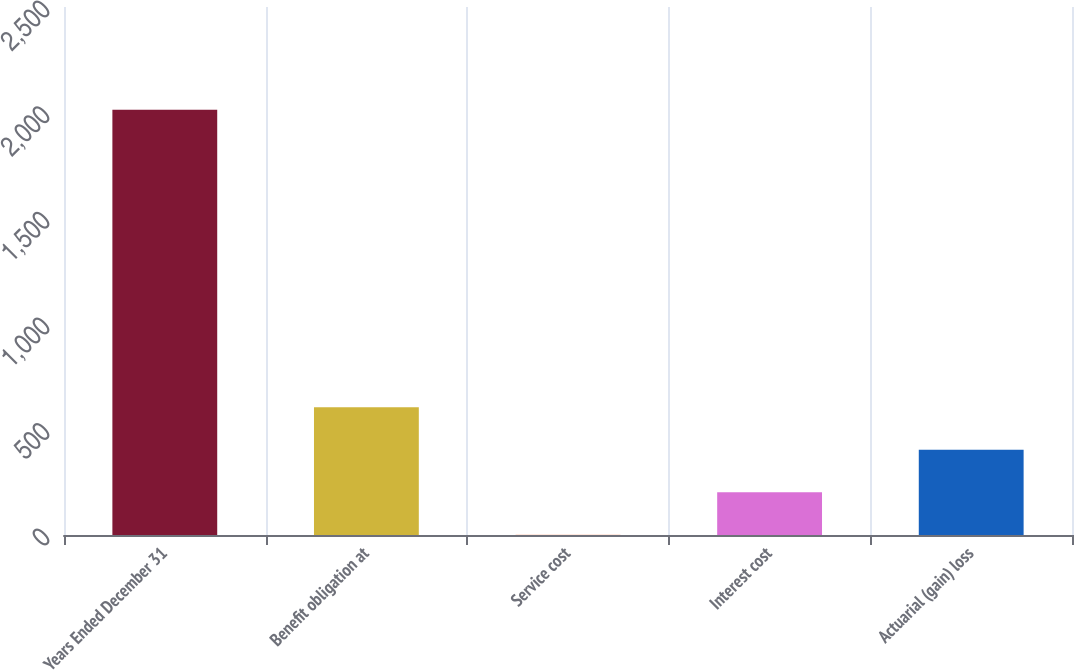Convert chart. <chart><loc_0><loc_0><loc_500><loc_500><bar_chart><fcel>Years Ended December 31<fcel>Benefit obligation at<fcel>Service cost<fcel>Interest cost<fcel>Actuarial (gain) loss<nl><fcel>2013<fcel>604.6<fcel>1<fcel>202.2<fcel>403.4<nl></chart> 